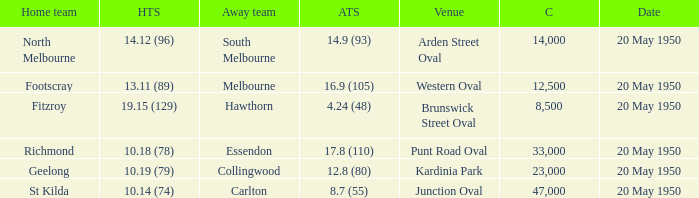What was the date of the game when the away team was south melbourne? 20 May 1950. 